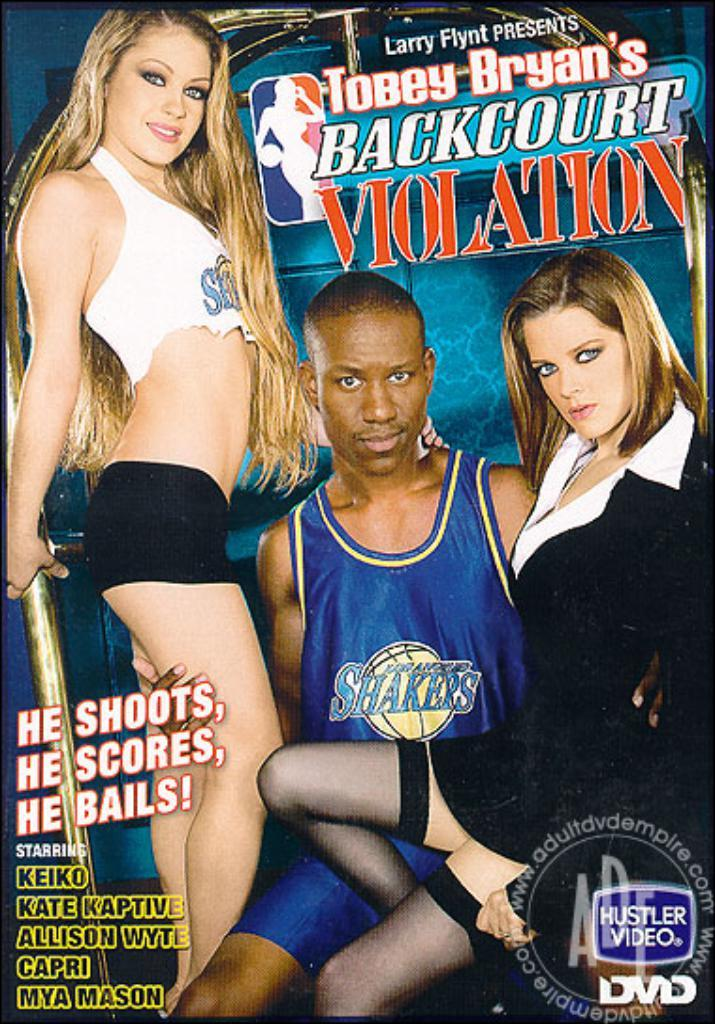<image>
Render a clear and concise summary of the photo. a man on a DVD cover that says violation on it 